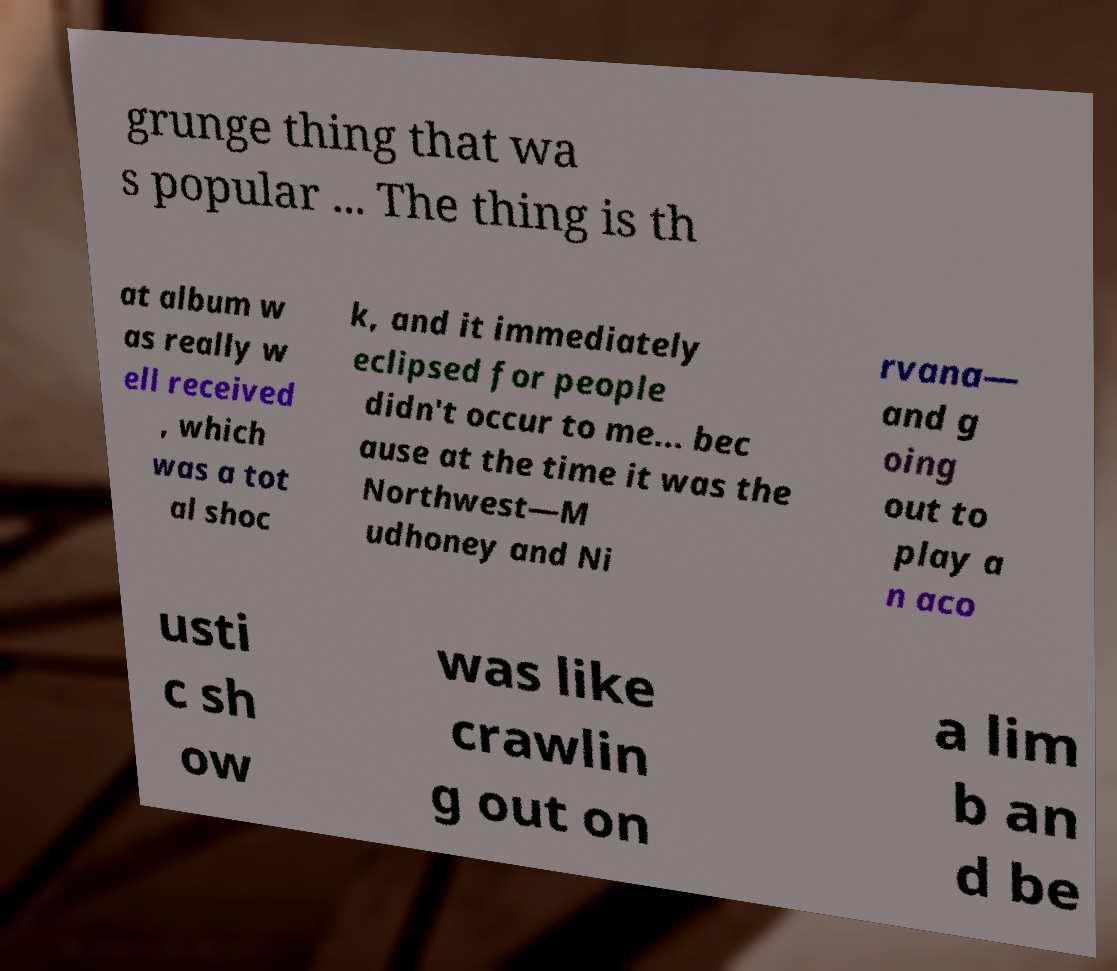Please read and relay the text visible in this image. What does it say? grunge thing that wa s popular ... The thing is th at album w as really w ell received , which was a tot al shoc k, and it immediately eclipsed for people didn't occur to me... bec ause at the time it was the Northwest—M udhoney and Ni rvana— and g oing out to play a n aco usti c sh ow was like crawlin g out on a lim b an d be 